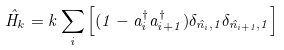<formula> <loc_0><loc_0><loc_500><loc_500>\hat { H } _ { k } = k \sum _ { i } \left [ ( 1 - a _ { i } ^ { \dagger } a _ { i + 1 } ^ { \dagger } ) \delta _ { \hat { n } _ { i } , 1 } \delta _ { \hat { n } _ { i + 1 } , 1 } \right ]</formula> 